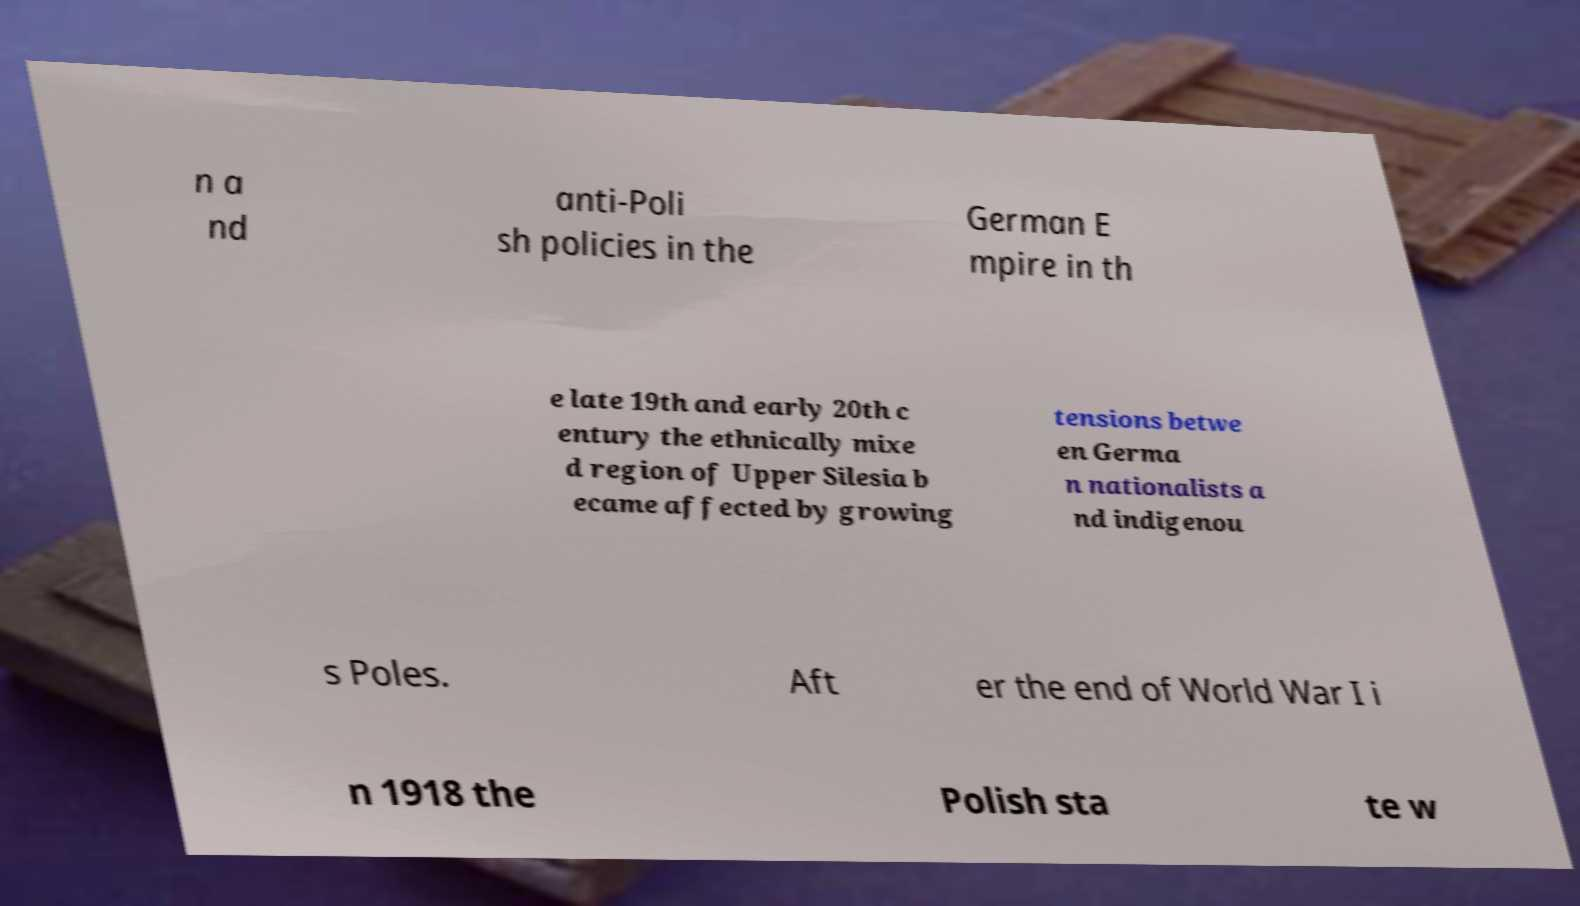Can you accurately transcribe the text from the provided image for me? n a nd anti-Poli sh policies in the German E mpire in th e late 19th and early 20th c entury the ethnically mixe d region of Upper Silesia b ecame affected by growing tensions betwe en Germa n nationalists a nd indigenou s Poles. Aft er the end of World War I i n 1918 the Polish sta te w 